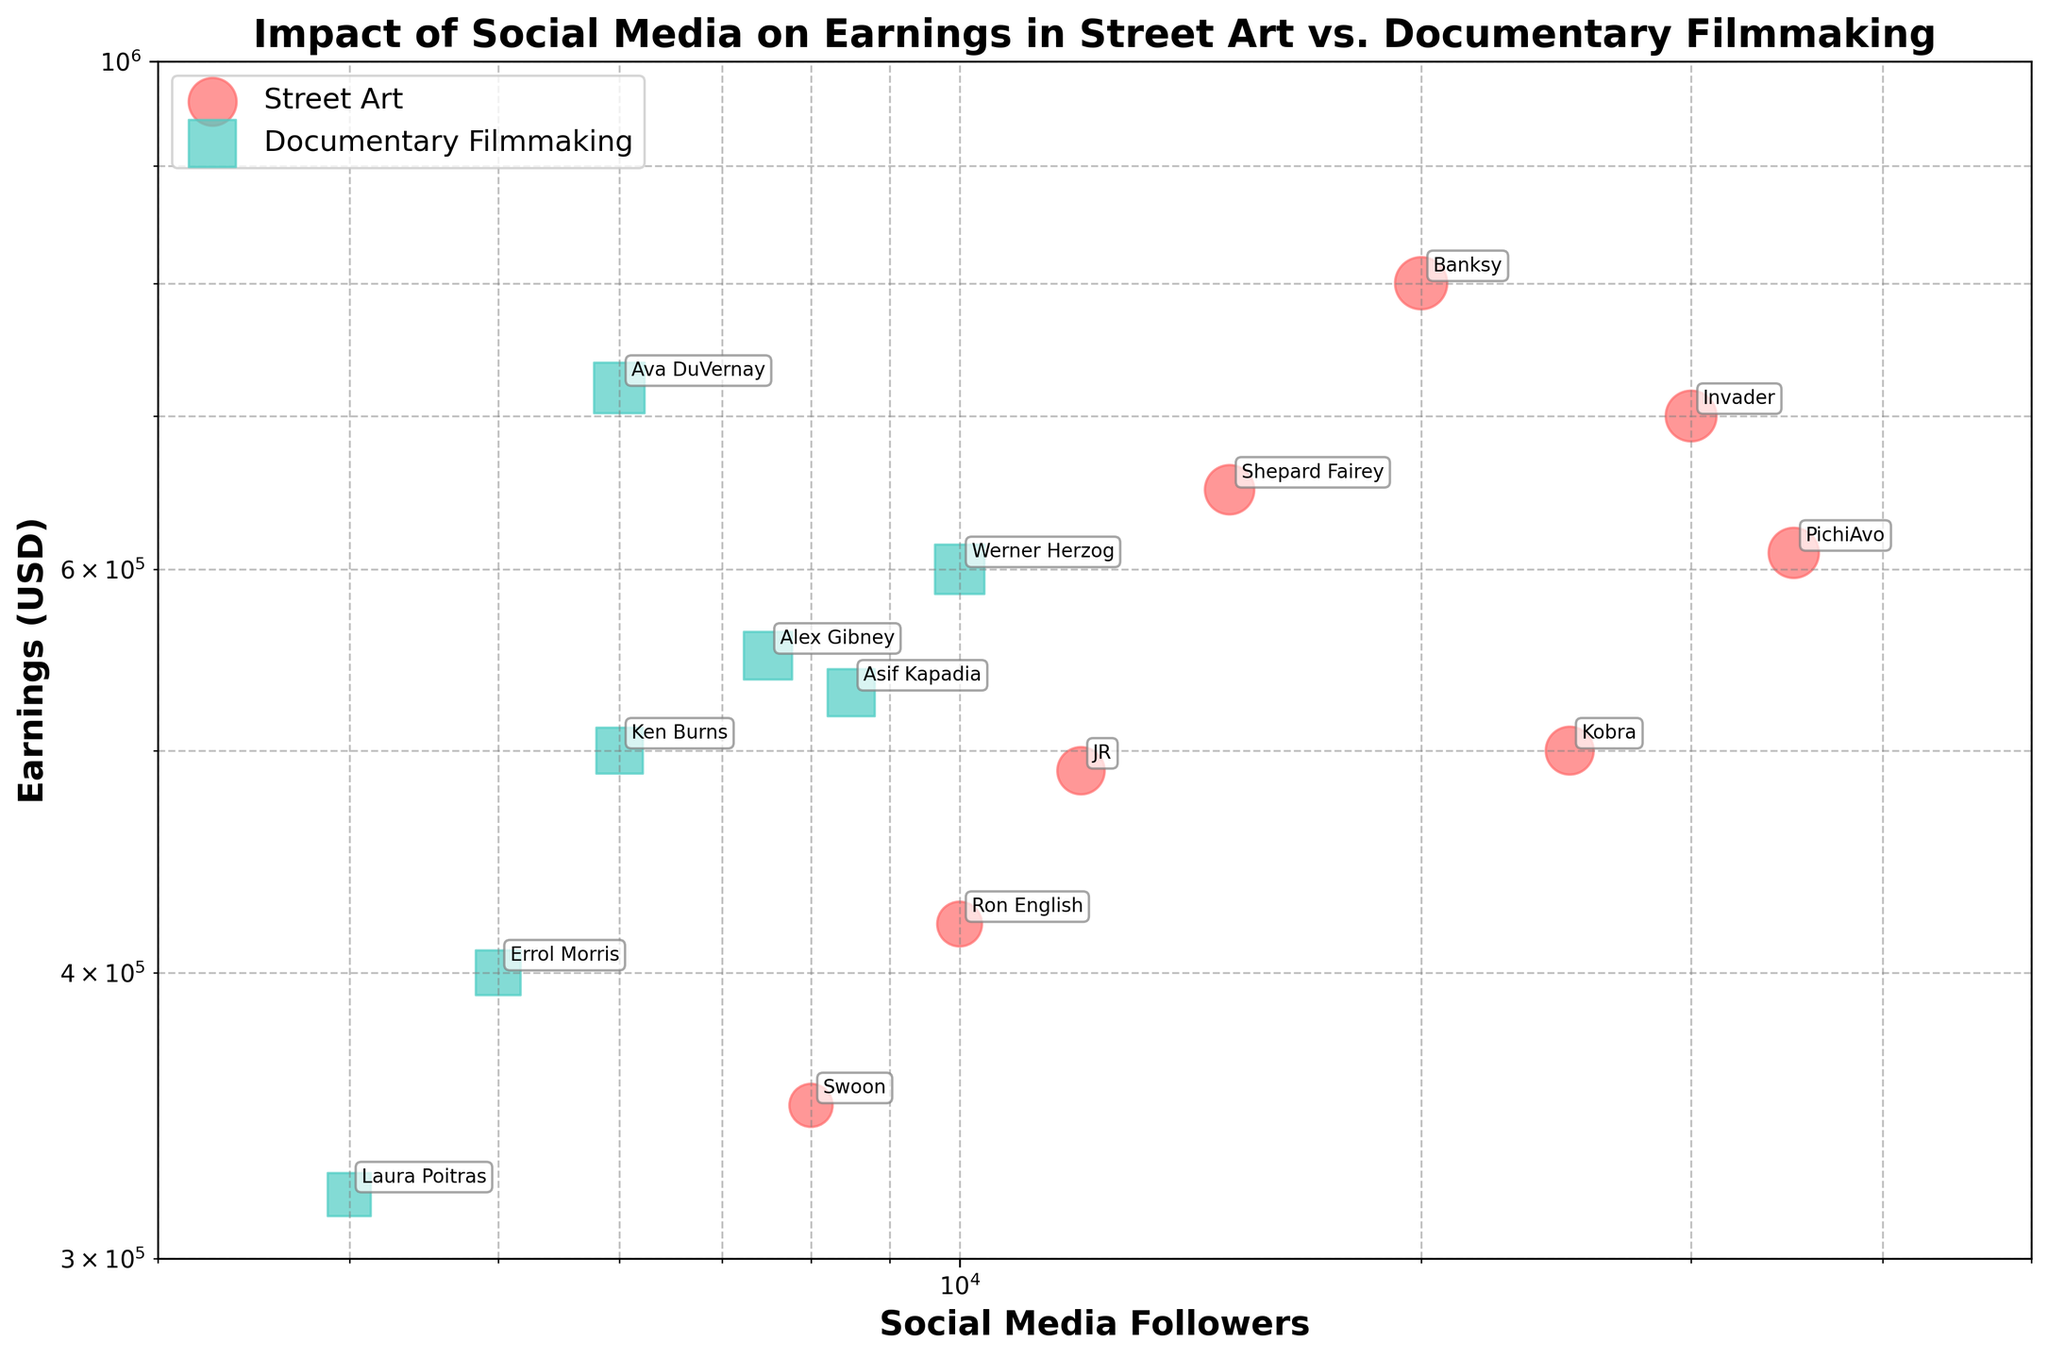How many artists in total are represented in the figure? To find the total number of artists, count the number of unique labels (names) annotated in the plot. There are 7 street artists and 7 documentary filmmakers, totaling 14 artists.
Answer: 14 What is the title of the figure? The title is always located at the top center of the figure. In this case, it states: "Impact of Social Media on Earnings in Street Art vs. Documentary Filmmaking".
Answer: Impact of Social Media on Earnings in Street Art vs. Documentary Filmmaking Which field has higher earnings on average, Street Art or Documentary Filmmaking? First, identify the earnings for all artists labeled within each field. Then calculate the average earnings for each field. Street Art: (800000 + 650000 + 700000 + 420000 + 500000 + 610000 + 490000 + 350000) / 8 = 627500. Documentary Filmmaking: (500000 + 400000 + 600000 + 550000 + 720000 + 530000 + 320000) / 7 = 517142.86. Street Art has higher average earnings.
Answer: Street Art Who has the highest earnings among street artists? Look for the label with the highest y-value among the points representing street artists. In this case, the highest point represents Banksy with earnings of 800,000 USD.
Answer: Banksy Which artist has the lowest number of social media followers? Identify the point positioned farthest to the left on the x-axis, because social media followers are plotted on a logarithmic scale. Laura Poitras in Documentary Filmmaking has 4,000 social media followers, which is the lowest.
Answer: Laura Poitras Between Ava DuVernay and JR, who has higher popularity and by how much? Find the popularity scores in the annotations of each artist. Ava DuVernay has a popularity score of 90, and JR has 78. The difference in popularity is 90 - 78 = 12.
Answer: Ava DuVernay, 12 How many street artists have more than 20,000 social media followers? Count the number of street artists whose social media followers exceed 20,000 on the x-axis. These are Banksy, Invader, and PichiAvo, totaling 3 artists.
Answer: 3 What is the general trend between social media followers and earnings in documentary filmmaking? Observing the scatter plot, determine whether points generally move upward (indicating a positive correlation) or downward (indicating a negative correlation) as the x-axis value increases. In documentary filmmaking, earnings tend to increase modestly with the number of social media followers, indicating a slight positive correlation.
Answer: Slight positive correlation Who among the group has the smallest average post interactions, and what is their number of interactions? Search for the annotations indicating the lowest point on the y-axis for average post interactions. Errol Morris in Documentary Filmmaking has the lowest with 350 interactions.
Answer: Errol Morris, 350 